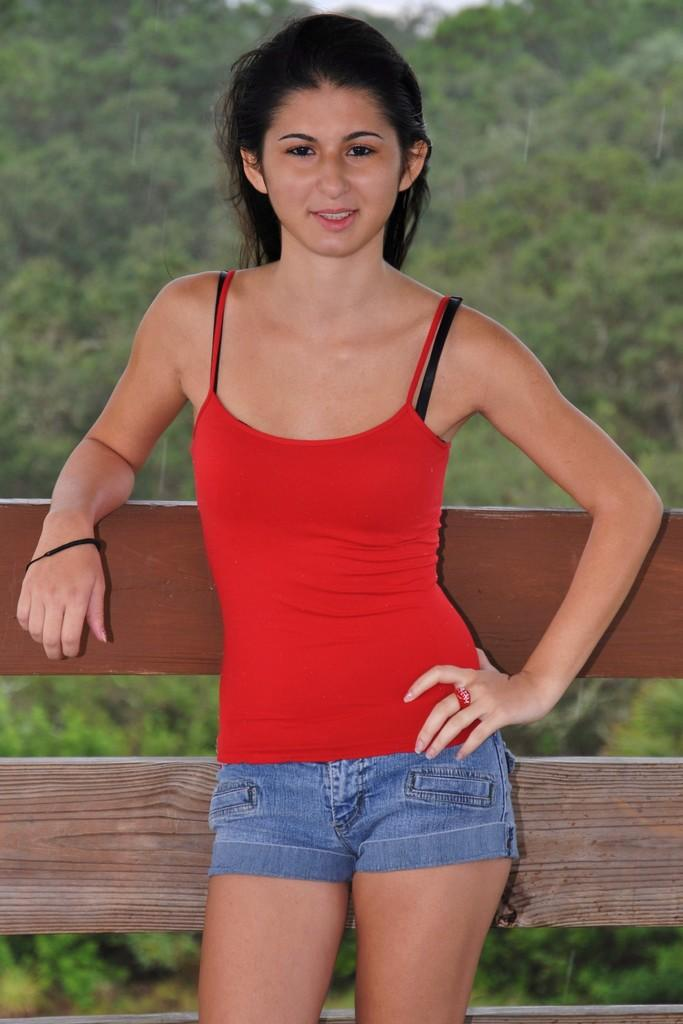Who is the main subject in the image? There is a girl in the image. What is the girl doing in the image? The girl is standing. What can be seen in the background of the image? There are trees in the background of the image. What material is visible in the image? There is wood visible in the image. What letters are being spelled out by the girl's chin in the image? There is no mention of letters or the girl's chin in the image, so this cannot be answered. 